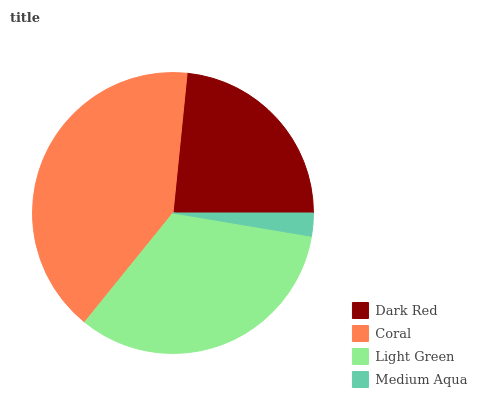Is Medium Aqua the minimum?
Answer yes or no. Yes. Is Coral the maximum?
Answer yes or no. Yes. Is Light Green the minimum?
Answer yes or no. No. Is Light Green the maximum?
Answer yes or no. No. Is Coral greater than Light Green?
Answer yes or no. Yes. Is Light Green less than Coral?
Answer yes or no. Yes. Is Light Green greater than Coral?
Answer yes or no. No. Is Coral less than Light Green?
Answer yes or no. No. Is Light Green the high median?
Answer yes or no. Yes. Is Dark Red the low median?
Answer yes or no. Yes. Is Dark Red the high median?
Answer yes or no. No. Is Medium Aqua the low median?
Answer yes or no. No. 